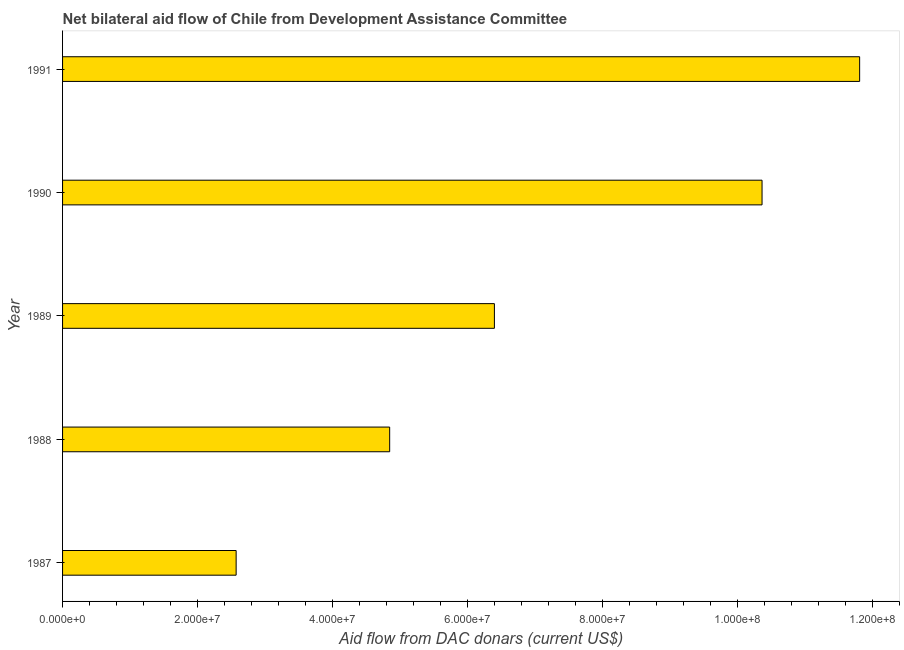Does the graph contain any zero values?
Your answer should be very brief. No. Does the graph contain grids?
Give a very brief answer. No. What is the title of the graph?
Provide a succinct answer. Net bilateral aid flow of Chile from Development Assistance Committee. What is the label or title of the X-axis?
Ensure brevity in your answer.  Aid flow from DAC donars (current US$). What is the net bilateral aid flows from dac donors in 1989?
Provide a succinct answer. 6.40e+07. Across all years, what is the maximum net bilateral aid flows from dac donors?
Offer a very short reply. 1.18e+08. Across all years, what is the minimum net bilateral aid flows from dac donors?
Offer a very short reply. 2.57e+07. In which year was the net bilateral aid flows from dac donors maximum?
Provide a succinct answer. 1991. What is the sum of the net bilateral aid flows from dac donors?
Your response must be concise. 3.60e+08. What is the difference between the net bilateral aid flows from dac donors in 1988 and 1989?
Your response must be concise. -1.55e+07. What is the average net bilateral aid flows from dac donors per year?
Your response must be concise. 7.20e+07. What is the median net bilateral aid flows from dac donors?
Offer a very short reply. 6.40e+07. Do a majority of the years between 1991 and 1989 (inclusive) have net bilateral aid flows from dac donors greater than 8000000 US$?
Keep it short and to the point. Yes. What is the ratio of the net bilateral aid flows from dac donors in 1987 to that in 1990?
Ensure brevity in your answer.  0.25. Is the net bilateral aid flows from dac donors in 1987 less than that in 1989?
Your answer should be compact. Yes. What is the difference between the highest and the second highest net bilateral aid flows from dac donors?
Ensure brevity in your answer.  1.45e+07. What is the difference between the highest and the lowest net bilateral aid flows from dac donors?
Keep it short and to the point. 9.24e+07. In how many years, is the net bilateral aid flows from dac donors greater than the average net bilateral aid flows from dac donors taken over all years?
Your answer should be compact. 2. How many bars are there?
Your response must be concise. 5. Are the values on the major ticks of X-axis written in scientific E-notation?
Give a very brief answer. Yes. What is the Aid flow from DAC donars (current US$) of 1987?
Provide a succinct answer. 2.57e+07. What is the Aid flow from DAC donars (current US$) in 1988?
Ensure brevity in your answer.  4.85e+07. What is the Aid flow from DAC donars (current US$) in 1989?
Keep it short and to the point. 6.40e+07. What is the Aid flow from DAC donars (current US$) of 1990?
Keep it short and to the point. 1.04e+08. What is the Aid flow from DAC donars (current US$) in 1991?
Your answer should be compact. 1.18e+08. What is the difference between the Aid flow from DAC donars (current US$) in 1987 and 1988?
Your answer should be compact. -2.28e+07. What is the difference between the Aid flow from DAC donars (current US$) in 1987 and 1989?
Give a very brief answer. -3.83e+07. What is the difference between the Aid flow from DAC donars (current US$) in 1987 and 1990?
Offer a very short reply. -7.79e+07. What is the difference between the Aid flow from DAC donars (current US$) in 1987 and 1991?
Give a very brief answer. -9.24e+07. What is the difference between the Aid flow from DAC donars (current US$) in 1988 and 1989?
Ensure brevity in your answer.  -1.55e+07. What is the difference between the Aid flow from DAC donars (current US$) in 1988 and 1990?
Keep it short and to the point. -5.52e+07. What is the difference between the Aid flow from DAC donars (current US$) in 1988 and 1991?
Offer a terse response. -6.96e+07. What is the difference between the Aid flow from DAC donars (current US$) in 1989 and 1990?
Your response must be concise. -3.97e+07. What is the difference between the Aid flow from DAC donars (current US$) in 1989 and 1991?
Your response must be concise. -5.41e+07. What is the difference between the Aid flow from DAC donars (current US$) in 1990 and 1991?
Your answer should be compact. -1.45e+07. What is the ratio of the Aid flow from DAC donars (current US$) in 1987 to that in 1988?
Provide a succinct answer. 0.53. What is the ratio of the Aid flow from DAC donars (current US$) in 1987 to that in 1989?
Offer a terse response. 0.4. What is the ratio of the Aid flow from DAC donars (current US$) in 1987 to that in 1990?
Provide a short and direct response. 0.25. What is the ratio of the Aid flow from DAC donars (current US$) in 1987 to that in 1991?
Provide a short and direct response. 0.22. What is the ratio of the Aid flow from DAC donars (current US$) in 1988 to that in 1989?
Offer a very short reply. 0.76. What is the ratio of the Aid flow from DAC donars (current US$) in 1988 to that in 1990?
Your answer should be very brief. 0.47. What is the ratio of the Aid flow from DAC donars (current US$) in 1988 to that in 1991?
Your answer should be compact. 0.41. What is the ratio of the Aid flow from DAC donars (current US$) in 1989 to that in 1990?
Provide a short and direct response. 0.62. What is the ratio of the Aid flow from DAC donars (current US$) in 1989 to that in 1991?
Offer a terse response. 0.54. What is the ratio of the Aid flow from DAC donars (current US$) in 1990 to that in 1991?
Your answer should be very brief. 0.88. 